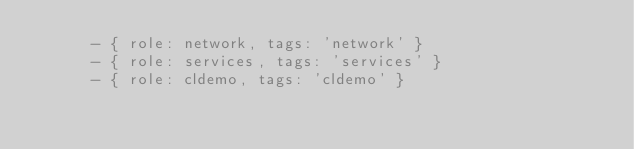<code> <loc_0><loc_0><loc_500><loc_500><_YAML_>      - { role: network, tags: 'network' }
      - { role: services, tags: 'services' }
      - { role: cldemo, tags: 'cldemo' }
</code> 